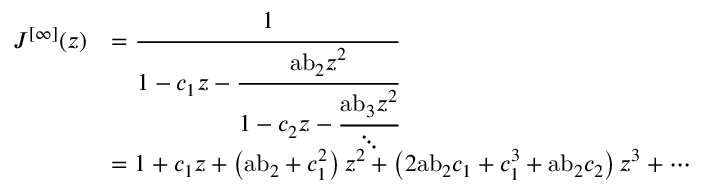Convert formula to latex. <formula><loc_0><loc_0><loc_500><loc_500>{ \begin{array} { r l } { J ^ { [ \infty ] } ( z ) } & { = { \cfrac { 1 } { 1 - c _ { 1 } z - { \cfrac { { a b } _ { 2 } z ^ { 2 } } { 1 - c _ { 2 } z - { \cfrac { { a b } _ { 3 } z ^ { 2 } } { \ddots } } } } } } } \\ & { = 1 + c _ { 1 } z + \left ( { a b } _ { 2 } + c _ { 1 } ^ { 2 } \right ) z ^ { 2 } + \left ( 2 { a b } _ { 2 } c _ { 1 } + c _ { 1 } ^ { 3 } + { a b } _ { 2 } c _ { 2 } \right ) z ^ { 3 } + \cdots } \end{array} }</formula> 